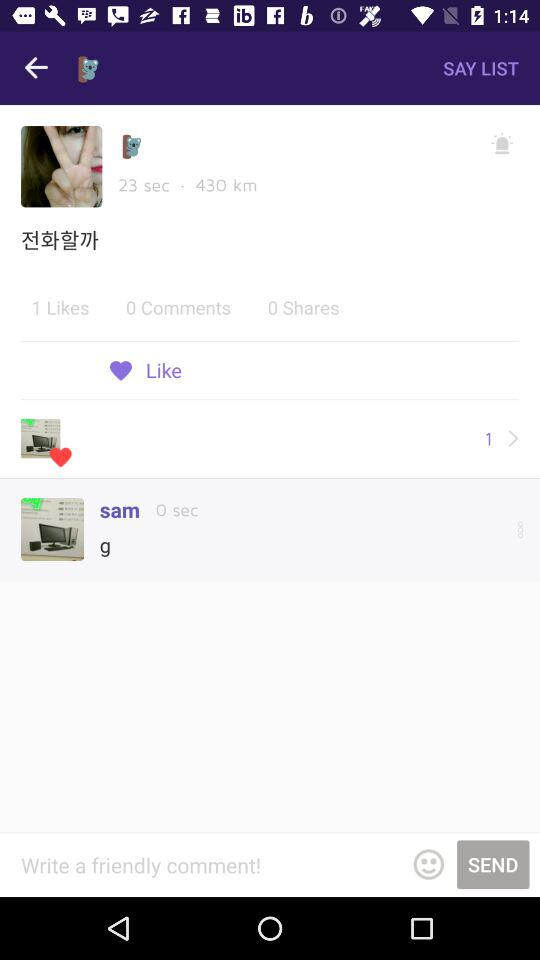How many more seconds than shares are there?
Answer the question using a single word or phrase. 23 